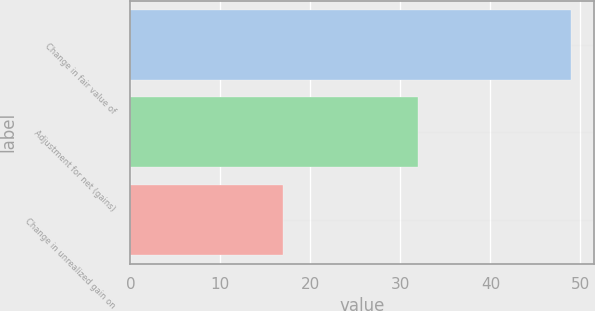Convert chart to OTSL. <chart><loc_0><loc_0><loc_500><loc_500><bar_chart><fcel>Change in fair value of<fcel>Adjustment for net (gains)<fcel>Change in unrealized gain on<nl><fcel>49<fcel>32<fcel>17<nl></chart> 